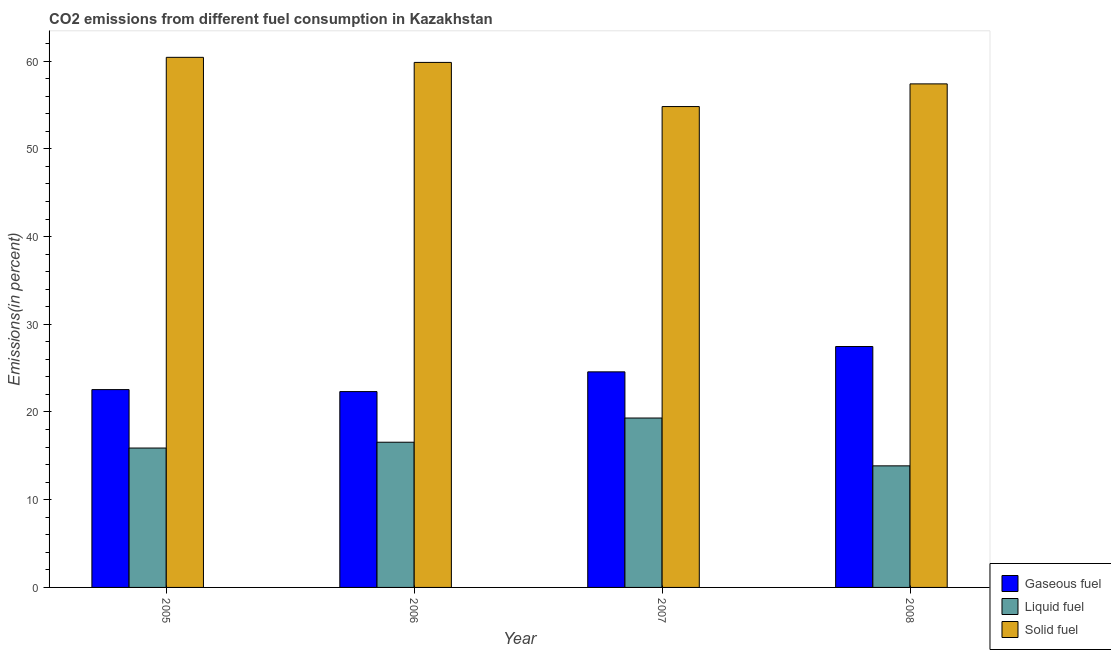Are the number of bars on each tick of the X-axis equal?
Your answer should be compact. Yes. What is the percentage of solid fuel emission in 2006?
Offer a very short reply. 59.85. Across all years, what is the maximum percentage of liquid fuel emission?
Your response must be concise. 19.31. Across all years, what is the minimum percentage of solid fuel emission?
Keep it short and to the point. 54.82. In which year was the percentage of solid fuel emission maximum?
Ensure brevity in your answer.  2005. What is the total percentage of solid fuel emission in the graph?
Your answer should be very brief. 232.52. What is the difference between the percentage of solid fuel emission in 2005 and that in 2007?
Your answer should be compact. 5.61. What is the difference between the percentage of gaseous fuel emission in 2007 and the percentage of liquid fuel emission in 2006?
Ensure brevity in your answer.  2.25. What is the average percentage of gaseous fuel emission per year?
Ensure brevity in your answer.  24.23. In how many years, is the percentage of solid fuel emission greater than 42 %?
Offer a very short reply. 4. What is the ratio of the percentage of liquid fuel emission in 2007 to that in 2008?
Your answer should be compact. 1.39. Is the difference between the percentage of gaseous fuel emission in 2006 and 2007 greater than the difference between the percentage of liquid fuel emission in 2006 and 2007?
Your answer should be compact. No. What is the difference between the highest and the second highest percentage of liquid fuel emission?
Keep it short and to the point. 2.76. What is the difference between the highest and the lowest percentage of gaseous fuel emission?
Give a very brief answer. 5.14. Is the sum of the percentage of liquid fuel emission in 2007 and 2008 greater than the maximum percentage of gaseous fuel emission across all years?
Keep it short and to the point. Yes. What does the 2nd bar from the left in 2006 represents?
Provide a succinct answer. Liquid fuel. What does the 3rd bar from the right in 2006 represents?
Your response must be concise. Gaseous fuel. Is it the case that in every year, the sum of the percentage of gaseous fuel emission and percentage of liquid fuel emission is greater than the percentage of solid fuel emission?
Ensure brevity in your answer.  No. How many years are there in the graph?
Give a very brief answer. 4. Are the values on the major ticks of Y-axis written in scientific E-notation?
Offer a terse response. No. Does the graph contain any zero values?
Your answer should be very brief. No. How many legend labels are there?
Give a very brief answer. 3. How are the legend labels stacked?
Offer a terse response. Vertical. What is the title of the graph?
Your answer should be compact. CO2 emissions from different fuel consumption in Kazakhstan. What is the label or title of the X-axis?
Provide a short and direct response. Year. What is the label or title of the Y-axis?
Your answer should be very brief. Emissions(in percent). What is the Emissions(in percent) in Gaseous fuel in 2005?
Your answer should be very brief. 22.55. What is the Emissions(in percent) of Liquid fuel in 2005?
Keep it short and to the point. 15.89. What is the Emissions(in percent) of Solid fuel in 2005?
Give a very brief answer. 60.43. What is the Emissions(in percent) in Gaseous fuel in 2006?
Your answer should be compact. 22.33. What is the Emissions(in percent) of Liquid fuel in 2006?
Offer a very short reply. 16.55. What is the Emissions(in percent) in Solid fuel in 2006?
Your answer should be very brief. 59.85. What is the Emissions(in percent) in Gaseous fuel in 2007?
Your answer should be very brief. 24.58. What is the Emissions(in percent) in Liquid fuel in 2007?
Make the answer very short. 19.31. What is the Emissions(in percent) in Solid fuel in 2007?
Your response must be concise. 54.82. What is the Emissions(in percent) in Gaseous fuel in 2008?
Give a very brief answer. 27.46. What is the Emissions(in percent) in Liquid fuel in 2008?
Offer a terse response. 13.86. What is the Emissions(in percent) of Solid fuel in 2008?
Provide a succinct answer. 57.41. Across all years, what is the maximum Emissions(in percent) of Gaseous fuel?
Provide a succinct answer. 27.46. Across all years, what is the maximum Emissions(in percent) in Liquid fuel?
Your answer should be compact. 19.31. Across all years, what is the maximum Emissions(in percent) in Solid fuel?
Give a very brief answer. 60.43. Across all years, what is the minimum Emissions(in percent) of Gaseous fuel?
Your answer should be very brief. 22.33. Across all years, what is the minimum Emissions(in percent) of Liquid fuel?
Make the answer very short. 13.86. Across all years, what is the minimum Emissions(in percent) of Solid fuel?
Your answer should be very brief. 54.82. What is the total Emissions(in percent) in Gaseous fuel in the graph?
Provide a short and direct response. 96.92. What is the total Emissions(in percent) of Liquid fuel in the graph?
Provide a short and direct response. 65.62. What is the total Emissions(in percent) of Solid fuel in the graph?
Offer a very short reply. 232.52. What is the difference between the Emissions(in percent) in Gaseous fuel in 2005 and that in 2006?
Provide a succinct answer. 0.23. What is the difference between the Emissions(in percent) of Liquid fuel in 2005 and that in 2006?
Provide a succinct answer. -0.66. What is the difference between the Emissions(in percent) of Solid fuel in 2005 and that in 2006?
Make the answer very short. 0.58. What is the difference between the Emissions(in percent) in Gaseous fuel in 2005 and that in 2007?
Your response must be concise. -2.02. What is the difference between the Emissions(in percent) of Liquid fuel in 2005 and that in 2007?
Ensure brevity in your answer.  -3.42. What is the difference between the Emissions(in percent) of Solid fuel in 2005 and that in 2007?
Give a very brief answer. 5.61. What is the difference between the Emissions(in percent) in Gaseous fuel in 2005 and that in 2008?
Give a very brief answer. -4.91. What is the difference between the Emissions(in percent) in Liquid fuel in 2005 and that in 2008?
Ensure brevity in your answer.  2.03. What is the difference between the Emissions(in percent) of Solid fuel in 2005 and that in 2008?
Provide a succinct answer. 3.03. What is the difference between the Emissions(in percent) of Gaseous fuel in 2006 and that in 2007?
Your answer should be compact. -2.25. What is the difference between the Emissions(in percent) of Liquid fuel in 2006 and that in 2007?
Ensure brevity in your answer.  -2.76. What is the difference between the Emissions(in percent) of Solid fuel in 2006 and that in 2007?
Your answer should be very brief. 5.03. What is the difference between the Emissions(in percent) in Gaseous fuel in 2006 and that in 2008?
Make the answer very short. -5.14. What is the difference between the Emissions(in percent) in Liquid fuel in 2006 and that in 2008?
Give a very brief answer. 2.69. What is the difference between the Emissions(in percent) in Solid fuel in 2006 and that in 2008?
Provide a succinct answer. 2.45. What is the difference between the Emissions(in percent) of Gaseous fuel in 2007 and that in 2008?
Offer a very short reply. -2.89. What is the difference between the Emissions(in percent) of Liquid fuel in 2007 and that in 2008?
Your response must be concise. 5.45. What is the difference between the Emissions(in percent) of Solid fuel in 2007 and that in 2008?
Provide a short and direct response. -2.58. What is the difference between the Emissions(in percent) in Gaseous fuel in 2005 and the Emissions(in percent) in Liquid fuel in 2006?
Your answer should be compact. 6. What is the difference between the Emissions(in percent) in Gaseous fuel in 2005 and the Emissions(in percent) in Solid fuel in 2006?
Provide a short and direct response. -37.3. What is the difference between the Emissions(in percent) of Liquid fuel in 2005 and the Emissions(in percent) of Solid fuel in 2006?
Your answer should be very brief. -43.96. What is the difference between the Emissions(in percent) in Gaseous fuel in 2005 and the Emissions(in percent) in Liquid fuel in 2007?
Give a very brief answer. 3.24. What is the difference between the Emissions(in percent) of Gaseous fuel in 2005 and the Emissions(in percent) of Solid fuel in 2007?
Offer a very short reply. -32.27. What is the difference between the Emissions(in percent) of Liquid fuel in 2005 and the Emissions(in percent) of Solid fuel in 2007?
Offer a very short reply. -38.93. What is the difference between the Emissions(in percent) of Gaseous fuel in 2005 and the Emissions(in percent) of Liquid fuel in 2008?
Provide a short and direct response. 8.69. What is the difference between the Emissions(in percent) of Gaseous fuel in 2005 and the Emissions(in percent) of Solid fuel in 2008?
Keep it short and to the point. -34.85. What is the difference between the Emissions(in percent) in Liquid fuel in 2005 and the Emissions(in percent) in Solid fuel in 2008?
Offer a very short reply. -41.52. What is the difference between the Emissions(in percent) in Gaseous fuel in 2006 and the Emissions(in percent) in Liquid fuel in 2007?
Offer a terse response. 3.02. What is the difference between the Emissions(in percent) in Gaseous fuel in 2006 and the Emissions(in percent) in Solid fuel in 2007?
Give a very brief answer. -32.49. What is the difference between the Emissions(in percent) in Liquid fuel in 2006 and the Emissions(in percent) in Solid fuel in 2007?
Make the answer very short. -38.27. What is the difference between the Emissions(in percent) in Gaseous fuel in 2006 and the Emissions(in percent) in Liquid fuel in 2008?
Offer a terse response. 8.47. What is the difference between the Emissions(in percent) in Gaseous fuel in 2006 and the Emissions(in percent) in Solid fuel in 2008?
Keep it short and to the point. -35.08. What is the difference between the Emissions(in percent) of Liquid fuel in 2006 and the Emissions(in percent) of Solid fuel in 2008?
Your answer should be very brief. -40.85. What is the difference between the Emissions(in percent) of Gaseous fuel in 2007 and the Emissions(in percent) of Liquid fuel in 2008?
Ensure brevity in your answer.  10.72. What is the difference between the Emissions(in percent) in Gaseous fuel in 2007 and the Emissions(in percent) in Solid fuel in 2008?
Offer a very short reply. -32.83. What is the difference between the Emissions(in percent) in Liquid fuel in 2007 and the Emissions(in percent) in Solid fuel in 2008?
Offer a very short reply. -38.09. What is the average Emissions(in percent) in Gaseous fuel per year?
Provide a succinct answer. 24.23. What is the average Emissions(in percent) of Liquid fuel per year?
Ensure brevity in your answer.  16.4. What is the average Emissions(in percent) in Solid fuel per year?
Your answer should be very brief. 58.13. In the year 2005, what is the difference between the Emissions(in percent) in Gaseous fuel and Emissions(in percent) in Liquid fuel?
Offer a very short reply. 6.66. In the year 2005, what is the difference between the Emissions(in percent) of Gaseous fuel and Emissions(in percent) of Solid fuel?
Give a very brief answer. -37.88. In the year 2005, what is the difference between the Emissions(in percent) in Liquid fuel and Emissions(in percent) in Solid fuel?
Make the answer very short. -44.54. In the year 2006, what is the difference between the Emissions(in percent) of Gaseous fuel and Emissions(in percent) of Liquid fuel?
Your answer should be very brief. 5.77. In the year 2006, what is the difference between the Emissions(in percent) in Gaseous fuel and Emissions(in percent) in Solid fuel?
Provide a succinct answer. -37.53. In the year 2006, what is the difference between the Emissions(in percent) of Liquid fuel and Emissions(in percent) of Solid fuel?
Ensure brevity in your answer.  -43.3. In the year 2007, what is the difference between the Emissions(in percent) in Gaseous fuel and Emissions(in percent) in Liquid fuel?
Give a very brief answer. 5.26. In the year 2007, what is the difference between the Emissions(in percent) of Gaseous fuel and Emissions(in percent) of Solid fuel?
Offer a very short reply. -30.25. In the year 2007, what is the difference between the Emissions(in percent) in Liquid fuel and Emissions(in percent) in Solid fuel?
Your response must be concise. -35.51. In the year 2008, what is the difference between the Emissions(in percent) of Gaseous fuel and Emissions(in percent) of Liquid fuel?
Make the answer very short. 13.6. In the year 2008, what is the difference between the Emissions(in percent) in Gaseous fuel and Emissions(in percent) in Solid fuel?
Give a very brief answer. -29.94. In the year 2008, what is the difference between the Emissions(in percent) in Liquid fuel and Emissions(in percent) in Solid fuel?
Provide a short and direct response. -43.55. What is the ratio of the Emissions(in percent) in Solid fuel in 2005 to that in 2006?
Provide a short and direct response. 1.01. What is the ratio of the Emissions(in percent) in Gaseous fuel in 2005 to that in 2007?
Your answer should be very brief. 0.92. What is the ratio of the Emissions(in percent) in Liquid fuel in 2005 to that in 2007?
Your answer should be compact. 0.82. What is the ratio of the Emissions(in percent) of Solid fuel in 2005 to that in 2007?
Provide a succinct answer. 1.1. What is the ratio of the Emissions(in percent) in Gaseous fuel in 2005 to that in 2008?
Provide a short and direct response. 0.82. What is the ratio of the Emissions(in percent) in Liquid fuel in 2005 to that in 2008?
Your answer should be compact. 1.15. What is the ratio of the Emissions(in percent) in Solid fuel in 2005 to that in 2008?
Ensure brevity in your answer.  1.05. What is the ratio of the Emissions(in percent) in Gaseous fuel in 2006 to that in 2007?
Provide a succinct answer. 0.91. What is the ratio of the Emissions(in percent) in Liquid fuel in 2006 to that in 2007?
Make the answer very short. 0.86. What is the ratio of the Emissions(in percent) of Solid fuel in 2006 to that in 2007?
Your answer should be compact. 1.09. What is the ratio of the Emissions(in percent) of Gaseous fuel in 2006 to that in 2008?
Make the answer very short. 0.81. What is the ratio of the Emissions(in percent) in Liquid fuel in 2006 to that in 2008?
Keep it short and to the point. 1.19. What is the ratio of the Emissions(in percent) of Solid fuel in 2006 to that in 2008?
Provide a short and direct response. 1.04. What is the ratio of the Emissions(in percent) in Gaseous fuel in 2007 to that in 2008?
Keep it short and to the point. 0.89. What is the ratio of the Emissions(in percent) of Liquid fuel in 2007 to that in 2008?
Offer a terse response. 1.39. What is the ratio of the Emissions(in percent) in Solid fuel in 2007 to that in 2008?
Ensure brevity in your answer.  0.95. What is the difference between the highest and the second highest Emissions(in percent) in Gaseous fuel?
Give a very brief answer. 2.89. What is the difference between the highest and the second highest Emissions(in percent) of Liquid fuel?
Provide a short and direct response. 2.76. What is the difference between the highest and the second highest Emissions(in percent) in Solid fuel?
Keep it short and to the point. 0.58. What is the difference between the highest and the lowest Emissions(in percent) in Gaseous fuel?
Your answer should be very brief. 5.14. What is the difference between the highest and the lowest Emissions(in percent) of Liquid fuel?
Provide a short and direct response. 5.45. What is the difference between the highest and the lowest Emissions(in percent) in Solid fuel?
Your answer should be compact. 5.61. 